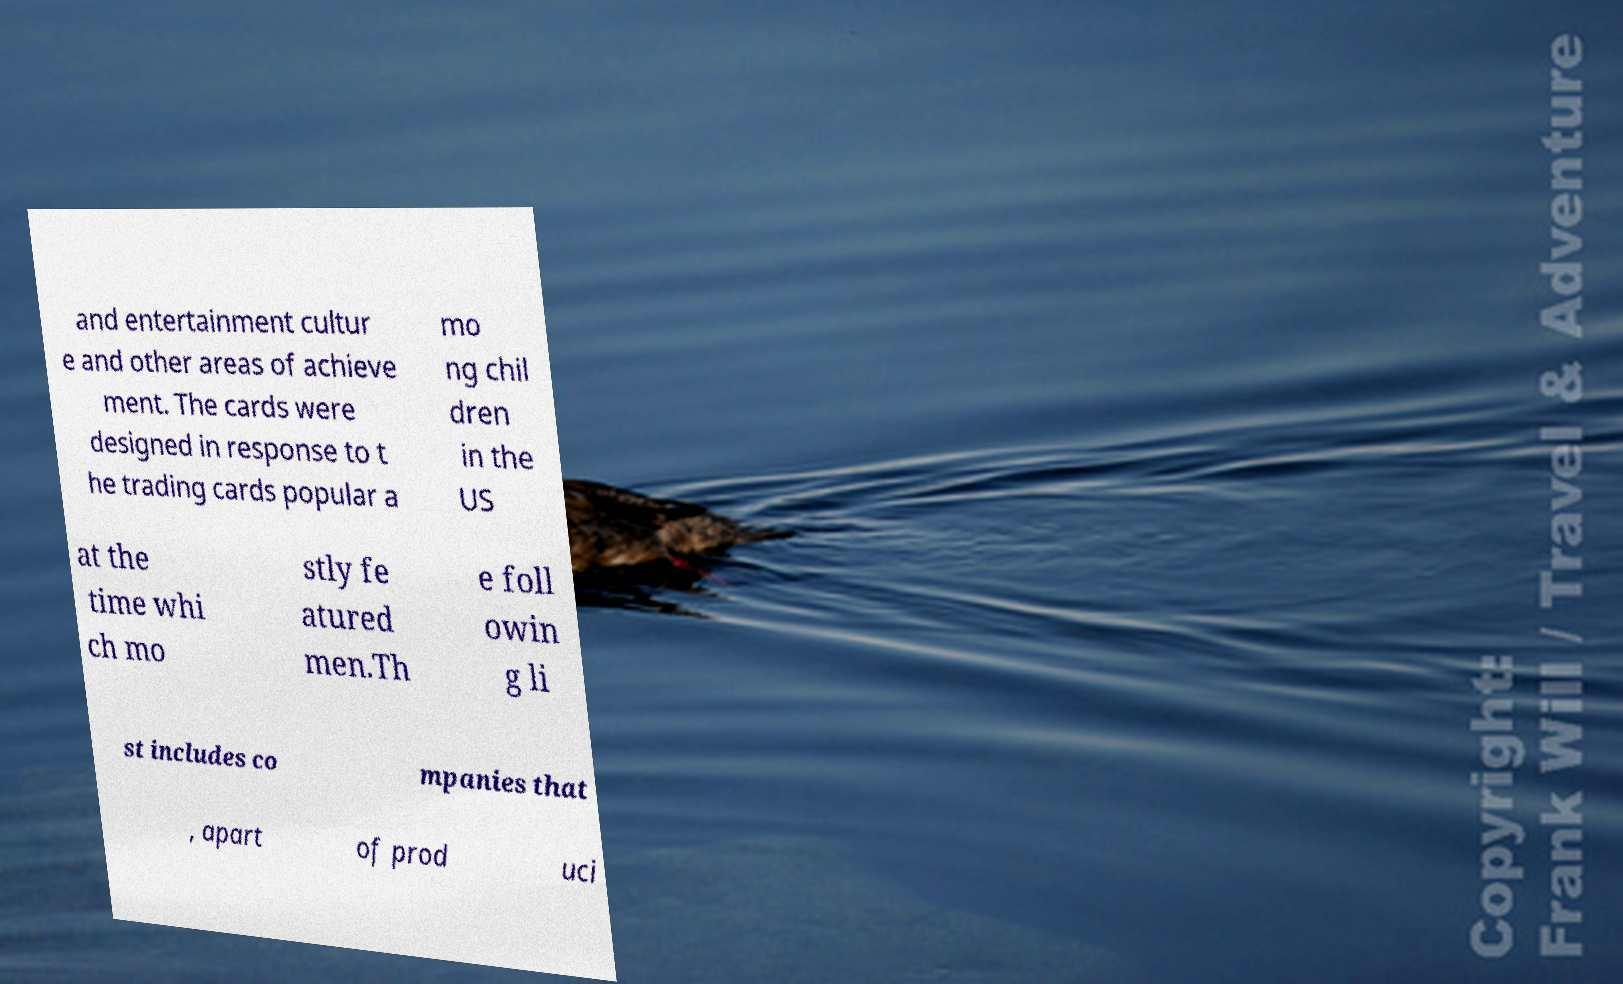What messages or text are displayed in this image? I need them in a readable, typed format. and entertainment cultur e and other areas of achieve ment. The cards were designed in response to t he trading cards popular a mo ng chil dren in the US at the time whi ch mo stly fe atured men.Th e foll owin g li st includes co mpanies that , apart of prod uci 